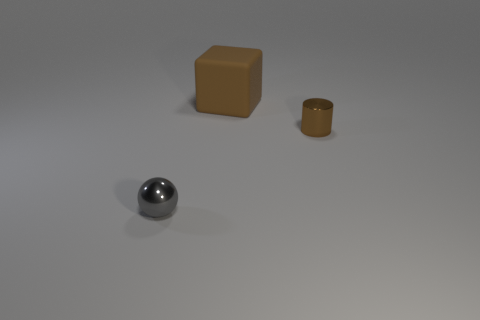There is a thing that is in front of the rubber object and behind the gray shiny thing; what color is it? The object in question appears to be a brown cylindrical container, positioned between the rubber-esque orange cube and the reflective gray sphere. 